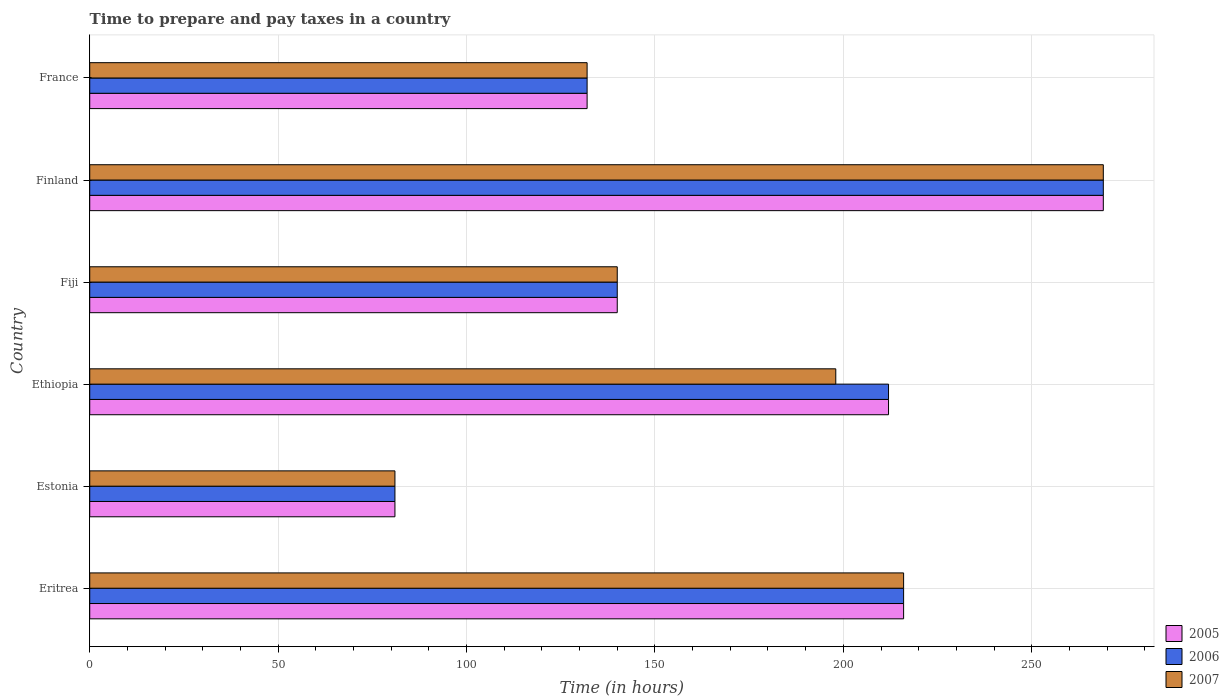How many groups of bars are there?
Offer a terse response. 6. What is the label of the 4th group of bars from the top?
Provide a succinct answer. Ethiopia. In how many cases, is the number of bars for a given country not equal to the number of legend labels?
Provide a short and direct response. 0. What is the number of hours required to prepare and pay taxes in 2006 in Eritrea?
Provide a succinct answer. 216. Across all countries, what is the maximum number of hours required to prepare and pay taxes in 2006?
Give a very brief answer. 269. Across all countries, what is the minimum number of hours required to prepare and pay taxes in 2006?
Offer a very short reply. 81. In which country was the number of hours required to prepare and pay taxes in 2005 minimum?
Provide a succinct answer. Estonia. What is the total number of hours required to prepare and pay taxes in 2006 in the graph?
Your answer should be compact. 1050. What is the difference between the number of hours required to prepare and pay taxes in 2006 in Estonia and that in France?
Offer a terse response. -51. What is the difference between the number of hours required to prepare and pay taxes in 2007 in Eritrea and the number of hours required to prepare and pay taxes in 2006 in Finland?
Your answer should be very brief. -53. What is the average number of hours required to prepare and pay taxes in 2006 per country?
Ensure brevity in your answer.  175. What is the difference between the number of hours required to prepare and pay taxes in 2005 and number of hours required to prepare and pay taxes in 2007 in Fiji?
Keep it short and to the point. 0. In how many countries, is the number of hours required to prepare and pay taxes in 2006 greater than 150 hours?
Your response must be concise. 3. What is the ratio of the number of hours required to prepare and pay taxes in 2005 in Eritrea to that in Ethiopia?
Make the answer very short. 1.02. Is the difference between the number of hours required to prepare and pay taxes in 2005 in Ethiopia and Finland greater than the difference between the number of hours required to prepare and pay taxes in 2007 in Ethiopia and Finland?
Give a very brief answer. Yes. What is the difference between the highest and the second highest number of hours required to prepare and pay taxes in 2006?
Offer a terse response. 53. What is the difference between the highest and the lowest number of hours required to prepare and pay taxes in 2007?
Your answer should be very brief. 188. Is the sum of the number of hours required to prepare and pay taxes in 2007 in Fiji and Finland greater than the maximum number of hours required to prepare and pay taxes in 2005 across all countries?
Provide a short and direct response. Yes. Is it the case that in every country, the sum of the number of hours required to prepare and pay taxes in 2005 and number of hours required to prepare and pay taxes in 2007 is greater than the number of hours required to prepare and pay taxes in 2006?
Offer a very short reply. Yes. How are the legend labels stacked?
Offer a very short reply. Vertical. What is the title of the graph?
Your answer should be compact. Time to prepare and pay taxes in a country. What is the label or title of the X-axis?
Your answer should be very brief. Time (in hours). What is the Time (in hours) of 2005 in Eritrea?
Your answer should be very brief. 216. What is the Time (in hours) in 2006 in Eritrea?
Provide a short and direct response. 216. What is the Time (in hours) of 2007 in Eritrea?
Offer a terse response. 216. What is the Time (in hours) of 2007 in Estonia?
Make the answer very short. 81. What is the Time (in hours) in 2005 in Ethiopia?
Provide a succinct answer. 212. What is the Time (in hours) in 2006 in Ethiopia?
Offer a terse response. 212. What is the Time (in hours) in 2007 in Ethiopia?
Make the answer very short. 198. What is the Time (in hours) of 2005 in Fiji?
Your answer should be compact. 140. What is the Time (in hours) in 2006 in Fiji?
Your answer should be very brief. 140. What is the Time (in hours) of 2007 in Fiji?
Give a very brief answer. 140. What is the Time (in hours) in 2005 in Finland?
Your response must be concise. 269. What is the Time (in hours) of 2006 in Finland?
Ensure brevity in your answer.  269. What is the Time (in hours) in 2007 in Finland?
Provide a short and direct response. 269. What is the Time (in hours) in 2005 in France?
Provide a short and direct response. 132. What is the Time (in hours) of 2006 in France?
Your response must be concise. 132. What is the Time (in hours) of 2007 in France?
Offer a very short reply. 132. Across all countries, what is the maximum Time (in hours) of 2005?
Your answer should be very brief. 269. Across all countries, what is the maximum Time (in hours) in 2006?
Keep it short and to the point. 269. Across all countries, what is the maximum Time (in hours) of 2007?
Make the answer very short. 269. Across all countries, what is the minimum Time (in hours) of 2006?
Offer a very short reply. 81. Across all countries, what is the minimum Time (in hours) of 2007?
Ensure brevity in your answer.  81. What is the total Time (in hours) of 2005 in the graph?
Your answer should be very brief. 1050. What is the total Time (in hours) of 2006 in the graph?
Make the answer very short. 1050. What is the total Time (in hours) of 2007 in the graph?
Keep it short and to the point. 1036. What is the difference between the Time (in hours) in 2005 in Eritrea and that in Estonia?
Your response must be concise. 135. What is the difference between the Time (in hours) in 2006 in Eritrea and that in Estonia?
Provide a short and direct response. 135. What is the difference between the Time (in hours) of 2007 in Eritrea and that in Estonia?
Provide a succinct answer. 135. What is the difference between the Time (in hours) of 2005 in Eritrea and that in Ethiopia?
Your answer should be very brief. 4. What is the difference between the Time (in hours) in 2006 in Eritrea and that in Ethiopia?
Keep it short and to the point. 4. What is the difference between the Time (in hours) of 2007 in Eritrea and that in Ethiopia?
Keep it short and to the point. 18. What is the difference between the Time (in hours) in 2005 in Eritrea and that in Fiji?
Provide a succinct answer. 76. What is the difference between the Time (in hours) in 2006 in Eritrea and that in Fiji?
Your answer should be very brief. 76. What is the difference between the Time (in hours) in 2005 in Eritrea and that in Finland?
Ensure brevity in your answer.  -53. What is the difference between the Time (in hours) of 2006 in Eritrea and that in Finland?
Your answer should be very brief. -53. What is the difference between the Time (in hours) of 2007 in Eritrea and that in Finland?
Keep it short and to the point. -53. What is the difference between the Time (in hours) in 2006 in Eritrea and that in France?
Ensure brevity in your answer.  84. What is the difference between the Time (in hours) of 2007 in Eritrea and that in France?
Keep it short and to the point. 84. What is the difference between the Time (in hours) in 2005 in Estonia and that in Ethiopia?
Give a very brief answer. -131. What is the difference between the Time (in hours) in 2006 in Estonia and that in Ethiopia?
Make the answer very short. -131. What is the difference between the Time (in hours) in 2007 in Estonia and that in Ethiopia?
Offer a terse response. -117. What is the difference between the Time (in hours) of 2005 in Estonia and that in Fiji?
Offer a terse response. -59. What is the difference between the Time (in hours) in 2006 in Estonia and that in Fiji?
Provide a succinct answer. -59. What is the difference between the Time (in hours) of 2007 in Estonia and that in Fiji?
Give a very brief answer. -59. What is the difference between the Time (in hours) of 2005 in Estonia and that in Finland?
Keep it short and to the point. -188. What is the difference between the Time (in hours) of 2006 in Estonia and that in Finland?
Give a very brief answer. -188. What is the difference between the Time (in hours) in 2007 in Estonia and that in Finland?
Ensure brevity in your answer.  -188. What is the difference between the Time (in hours) in 2005 in Estonia and that in France?
Your response must be concise. -51. What is the difference between the Time (in hours) in 2006 in Estonia and that in France?
Provide a succinct answer. -51. What is the difference between the Time (in hours) of 2007 in Estonia and that in France?
Keep it short and to the point. -51. What is the difference between the Time (in hours) of 2006 in Ethiopia and that in Fiji?
Your answer should be very brief. 72. What is the difference between the Time (in hours) in 2005 in Ethiopia and that in Finland?
Make the answer very short. -57. What is the difference between the Time (in hours) of 2006 in Ethiopia and that in Finland?
Your answer should be very brief. -57. What is the difference between the Time (in hours) in 2007 in Ethiopia and that in Finland?
Your answer should be compact. -71. What is the difference between the Time (in hours) in 2005 in Ethiopia and that in France?
Your answer should be compact. 80. What is the difference between the Time (in hours) of 2007 in Ethiopia and that in France?
Ensure brevity in your answer.  66. What is the difference between the Time (in hours) in 2005 in Fiji and that in Finland?
Provide a short and direct response. -129. What is the difference between the Time (in hours) in 2006 in Fiji and that in Finland?
Offer a very short reply. -129. What is the difference between the Time (in hours) of 2007 in Fiji and that in Finland?
Provide a short and direct response. -129. What is the difference between the Time (in hours) of 2005 in Fiji and that in France?
Give a very brief answer. 8. What is the difference between the Time (in hours) of 2006 in Fiji and that in France?
Your answer should be very brief. 8. What is the difference between the Time (in hours) in 2005 in Finland and that in France?
Your answer should be compact. 137. What is the difference between the Time (in hours) in 2006 in Finland and that in France?
Your answer should be very brief. 137. What is the difference between the Time (in hours) in 2007 in Finland and that in France?
Keep it short and to the point. 137. What is the difference between the Time (in hours) of 2005 in Eritrea and the Time (in hours) of 2006 in Estonia?
Give a very brief answer. 135. What is the difference between the Time (in hours) in 2005 in Eritrea and the Time (in hours) in 2007 in Estonia?
Make the answer very short. 135. What is the difference between the Time (in hours) of 2006 in Eritrea and the Time (in hours) of 2007 in Estonia?
Give a very brief answer. 135. What is the difference between the Time (in hours) in 2005 in Eritrea and the Time (in hours) in 2006 in Ethiopia?
Your answer should be very brief. 4. What is the difference between the Time (in hours) of 2005 in Eritrea and the Time (in hours) of 2007 in Ethiopia?
Ensure brevity in your answer.  18. What is the difference between the Time (in hours) in 2006 in Eritrea and the Time (in hours) in 2007 in Ethiopia?
Offer a terse response. 18. What is the difference between the Time (in hours) of 2005 in Eritrea and the Time (in hours) of 2006 in Finland?
Give a very brief answer. -53. What is the difference between the Time (in hours) of 2005 in Eritrea and the Time (in hours) of 2007 in Finland?
Your answer should be very brief. -53. What is the difference between the Time (in hours) in 2006 in Eritrea and the Time (in hours) in 2007 in Finland?
Give a very brief answer. -53. What is the difference between the Time (in hours) in 2006 in Eritrea and the Time (in hours) in 2007 in France?
Provide a short and direct response. 84. What is the difference between the Time (in hours) of 2005 in Estonia and the Time (in hours) of 2006 in Ethiopia?
Your response must be concise. -131. What is the difference between the Time (in hours) of 2005 in Estonia and the Time (in hours) of 2007 in Ethiopia?
Your response must be concise. -117. What is the difference between the Time (in hours) in 2006 in Estonia and the Time (in hours) in 2007 in Ethiopia?
Your answer should be very brief. -117. What is the difference between the Time (in hours) of 2005 in Estonia and the Time (in hours) of 2006 in Fiji?
Provide a short and direct response. -59. What is the difference between the Time (in hours) in 2005 in Estonia and the Time (in hours) in 2007 in Fiji?
Your response must be concise. -59. What is the difference between the Time (in hours) of 2006 in Estonia and the Time (in hours) of 2007 in Fiji?
Keep it short and to the point. -59. What is the difference between the Time (in hours) in 2005 in Estonia and the Time (in hours) in 2006 in Finland?
Provide a succinct answer. -188. What is the difference between the Time (in hours) in 2005 in Estonia and the Time (in hours) in 2007 in Finland?
Offer a very short reply. -188. What is the difference between the Time (in hours) of 2006 in Estonia and the Time (in hours) of 2007 in Finland?
Ensure brevity in your answer.  -188. What is the difference between the Time (in hours) in 2005 in Estonia and the Time (in hours) in 2006 in France?
Make the answer very short. -51. What is the difference between the Time (in hours) of 2005 in Estonia and the Time (in hours) of 2007 in France?
Ensure brevity in your answer.  -51. What is the difference between the Time (in hours) in 2006 in Estonia and the Time (in hours) in 2007 in France?
Your response must be concise. -51. What is the difference between the Time (in hours) of 2005 in Ethiopia and the Time (in hours) of 2007 in Fiji?
Your answer should be very brief. 72. What is the difference between the Time (in hours) in 2005 in Ethiopia and the Time (in hours) in 2006 in Finland?
Your response must be concise. -57. What is the difference between the Time (in hours) of 2005 in Ethiopia and the Time (in hours) of 2007 in Finland?
Keep it short and to the point. -57. What is the difference between the Time (in hours) of 2006 in Ethiopia and the Time (in hours) of 2007 in Finland?
Offer a very short reply. -57. What is the difference between the Time (in hours) of 2005 in Ethiopia and the Time (in hours) of 2006 in France?
Give a very brief answer. 80. What is the difference between the Time (in hours) of 2005 in Ethiopia and the Time (in hours) of 2007 in France?
Your answer should be compact. 80. What is the difference between the Time (in hours) of 2005 in Fiji and the Time (in hours) of 2006 in Finland?
Provide a short and direct response. -129. What is the difference between the Time (in hours) of 2005 in Fiji and the Time (in hours) of 2007 in Finland?
Your response must be concise. -129. What is the difference between the Time (in hours) of 2006 in Fiji and the Time (in hours) of 2007 in Finland?
Provide a succinct answer. -129. What is the difference between the Time (in hours) in 2005 in Fiji and the Time (in hours) in 2006 in France?
Provide a succinct answer. 8. What is the difference between the Time (in hours) of 2005 in Fiji and the Time (in hours) of 2007 in France?
Your response must be concise. 8. What is the difference between the Time (in hours) of 2006 in Fiji and the Time (in hours) of 2007 in France?
Your answer should be very brief. 8. What is the difference between the Time (in hours) of 2005 in Finland and the Time (in hours) of 2006 in France?
Offer a terse response. 137. What is the difference between the Time (in hours) in 2005 in Finland and the Time (in hours) in 2007 in France?
Ensure brevity in your answer.  137. What is the difference between the Time (in hours) in 2006 in Finland and the Time (in hours) in 2007 in France?
Your response must be concise. 137. What is the average Time (in hours) in 2005 per country?
Make the answer very short. 175. What is the average Time (in hours) in 2006 per country?
Give a very brief answer. 175. What is the average Time (in hours) in 2007 per country?
Keep it short and to the point. 172.67. What is the difference between the Time (in hours) of 2006 and Time (in hours) of 2007 in Eritrea?
Ensure brevity in your answer.  0. What is the difference between the Time (in hours) in 2005 and Time (in hours) in 2006 in Estonia?
Offer a terse response. 0. What is the difference between the Time (in hours) of 2005 and Time (in hours) of 2006 in Ethiopia?
Your answer should be compact. 0. What is the difference between the Time (in hours) of 2005 and Time (in hours) of 2006 in Fiji?
Your answer should be compact. 0. What is the difference between the Time (in hours) of 2005 and Time (in hours) of 2007 in Fiji?
Provide a short and direct response. 0. What is the difference between the Time (in hours) of 2006 and Time (in hours) of 2007 in Fiji?
Your answer should be compact. 0. What is the difference between the Time (in hours) of 2005 and Time (in hours) of 2006 in Finland?
Give a very brief answer. 0. What is the difference between the Time (in hours) of 2005 and Time (in hours) of 2007 in Finland?
Your answer should be compact. 0. What is the ratio of the Time (in hours) of 2005 in Eritrea to that in Estonia?
Make the answer very short. 2.67. What is the ratio of the Time (in hours) in 2006 in Eritrea to that in Estonia?
Your response must be concise. 2.67. What is the ratio of the Time (in hours) in 2007 in Eritrea to that in Estonia?
Your answer should be very brief. 2.67. What is the ratio of the Time (in hours) in 2005 in Eritrea to that in Ethiopia?
Offer a very short reply. 1.02. What is the ratio of the Time (in hours) in 2006 in Eritrea to that in Ethiopia?
Keep it short and to the point. 1.02. What is the ratio of the Time (in hours) of 2005 in Eritrea to that in Fiji?
Give a very brief answer. 1.54. What is the ratio of the Time (in hours) in 2006 in Eritrea to that in Fiji?
Offer a terse response. 1.54. What is the ratio of the Time (in hours) of 2007 in Eritrea to that in Fiji?
Provide a succinct answer. 1.54. What is the ratio of the Time (in hours) in 2005 in Eritrea to that in Finland?
Keep it short and to the point. 0.8. What is the ratio of the Time (in hours) of 2006 in Eritrea to that in Finland?
Offer a terse response. 0.8. What is the ratio of the Time (in hours) in 2007 in Eritrea to that in Finland?
Provide a succinct answer. 0.8. What is the ratio of the Time (in hours) of 2005 in Eritrea to that in France?
Your answer should be very brief. 1.64. What is the ratio of the Time (in hours) of 2006 in Eritrea to that in France?
Make the answer very short. 1.64. What is the ratio of the Time (in hours) of 2007 in Eritrea to that in France?
Give a very brief answer. 1.64. What is the ratio of the Time (in hours) of 2005 in Estonia to that in Ethiopia?
Your answer should be very brief. 0.38. What is the ratio of the Time (in hours) in 2006 in Estonia to that in Ethiopia?
Your answer should be very brief. 0.38. What is the ratio of the Time (in hours) of 2007 in Estonia to that in Ethiopia?
Ensure brevity in your answer.  0.41. What is the ratio of the Time (in hours) in 2005 in Estonia to that in Fiji?
Give a very brief answer. 0.58. What is the ratio of the Time (in hours) in 2006 in Estonia to that in Fiji?
Make the answer very short. 0.58. What is the ratio of the Time (in hours) in 2007 in Estonia to that in Fiji?
Your answer should be very brief. 0.58. What is the ratio of the Time (in hours) in 2005 in Estonia to that in Finland?
Provide a succinct answer. 0.3. What is the ratio of the Time (in hours) of 2006 in Estonia to that in Finland?
Give a very brief answer. 0.3. What is the ratio of the Time (in hours) of 2007 in Estonia to that in Finland?
Provide a succinct answer. 0.3. What is the ratio of the Time (in hours) in 2005 in Estonia to that in France?
Offer a very short reply. 0.61. What is the ratio of the Time (in hours) of 2006 in Estonia to that in France?
Make the answer very short. 0.61. What is the ratio of the Time (in hours) in 2007 in Estonia to that in France?
Offer a terse response. 0.61. What is the ratio of the Time (in hours) in 2005 in Ethiopia to that in Fiji?
Provide a short and direct response. 1.51. What is the ratio of the Time (in hours) in 2006 in Ethiopia to that in Fiji?
Offer a terse response. 1.51. What is the ratio of the Time (in hours) of 2007 in Ethiopia to that in Fiji?
Provide a succinct answer. 1.41. What is the ratio of the Time (in hours) of 2005 in Ethiopia to that in Finland?
Provide a short and direct response. 0.79. What is the ratio of the Time (in hours) of 2006 in Ethiopia to that in Finland?
Provide a short and direct response. 0.79. What is the ratio of the Time (in hours) in 2007 in Ethiopia to that in Finland?
Offer a terse response. 0.74. What is the ratio of the Time (in hours) in 2005 in Ethiopia to that in France?
Offer a terse response. 1.61. What is the ratio of the Time (in hours) in 2006 in Ethiopia to that in France?
Your answer should be compact. 1.61. What is the ratio of the Time (in hours) of 2007 in Ethiopia to that in France?
Make the answer very short. 1.5. What is the ratio of the Time (in hours) of 2005 in Fiji to that in Finland?
Provide a short and direct response. 0.52. What is the ratio of the Time (in hours) of 2006 in Fiji to that in Finland?
Give a very brief answer. 0.52. What is the ratio of the Time (in hours) in 2007 in Fiji to that in Finland?
Offer a very short reply. 0.52. What is the ratio of the Time (in hours) of 2005 in Fiji to that in France?
Provide a succinct answer. 1.06. What is the ratio of the Time (in hours) of 2006 in Fiji to that in France?
Offer a very short reply. 1.06. What is the ratio of the Time (in hours) in 2007 in Fiji to that in France?
Your response must be concise. 1.06. What is the ratio of the Time (in hours) of 2005 in Finland to that in France?
Your answer should be compact. 2.04. What is the ratio of the Time (in hours) in 2006 in Finland to that in France?
Make the answer very short. 2.04. What is the ratio of the Time (in hours) of 2007 in Finland to that in France?
Your answer should be very brief. 2.04. What is the difference between the highest and the second highest Time (in hours) in 2005?
Ensure brevity in your answer.  53. What is the difference between the highest and the second highest Time (in hours) in 2007?
Your answer should be compact. 53. What is the difference between the highest and the lowest Time (in hours) in 2005?
Ensure brevity in your answer.  188. What is the difference between the highest and the lowest Time (in hours) in 2006?
Keep it short and to the point. 188. What is the difference between the highest and the lowest Time (in hours) of 2007?
Make the answer very short. 188. 